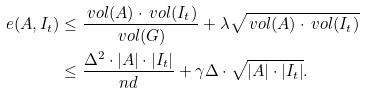Convert formula to latex. <formula><loc_0><loc_0><loc_500><loc_500>e ( A , I _ { t } ) & \leq \frac { \ v o l ( A ) \cdot \ v o l ( I _ { t } ) } { \ v o l ( G ) } + \lambda \sqrt { \ v o l ( A ) \cdot \ v o l ( I _ { t } ) } \\ & \leq \frac { \Delta ^ { 2 } \cdot | A | \cdot | I _ { t } | } { n d } + \gamma \Delta \cdot \sqrt { | A | \cdot | I _ { t } | } .</formula> 